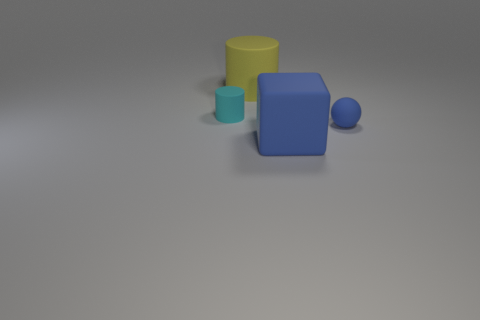How many big green rubber cylinders are there?
Ensure brevity in your answer.  0. Is the material of the small blue sphere the same as the big object that is in front of the big yellow cylinder?
Offer a terse response. Yes. There is a block that is the same color as the matte ball; what is it made of?
Your response must be concise. Rubber. How many small balls are the same color as the matte block?
Offer a very short reply. 1. The blue block is what size?
Ensure brevity in your answer.  Large. Do the big yellow matte thing and the tiny rubber thing left of the large blue object have the same shape?
Give a very brief answer. Yes. There is another big cylinder that is the same material as the cyan cylinder; what is its color?
Give a very brief answer. Yellow. There is a cylinder behind the tiny cyan cylinder; how big is it?
Provide a short and direct response. Large. Is the number of large blue matte blocks that are to the left of the large yellow cylinder less than the number of tiny blue balls?
Offer a very short reply. Yes. Does the tiny matte sphere have the same color as the cube?
Offer a very short reply. Yes. 